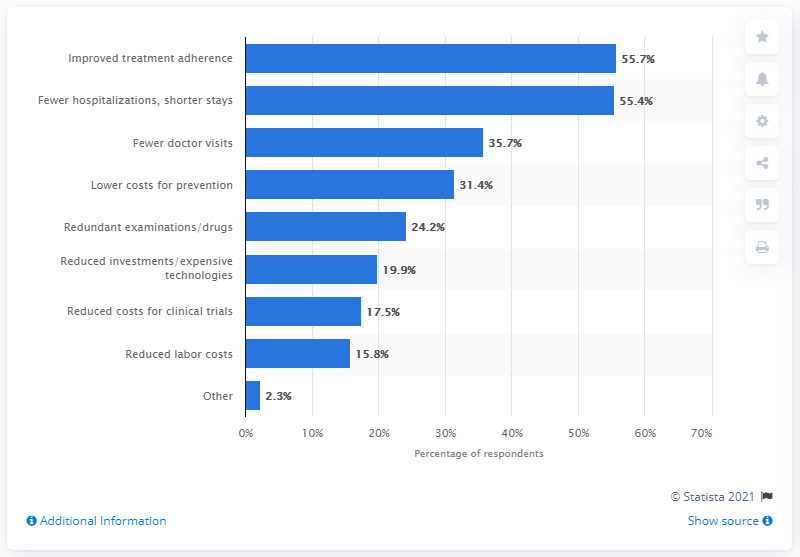What are the perceived benefits from lower costs for prevention according to the chart? The chart indicates that 31.4% of respondents view lower costs for prevention as a potential benefit. This reflects a considerable appreciation for preventive measures, which can help reduce more significant expenses related to treating advanced stages of illnesses later on. 